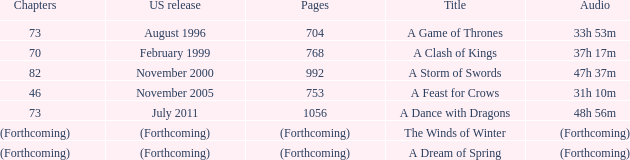How many pages does a dream of spring have? (Forthcoming). 